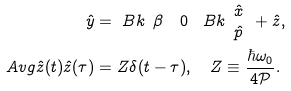<formula> <loc_0><loc_0><loc_500><loc_500>\hat { y } & = \ B k { \begin{array} { c c } \beta & 0 \end{array} } \ B k { \begin{array} { c } \hat { x } \\ \hat { p } \end{array} } + \hat { z } , \\ \ A v g { \hat { z } ( t ) \hat { z } ( \tau ) } & = Z \delta ( t - \tau ) , \quad Z \equiv \frac { \hbar { \omega } _ { 0 } } { 4 \mathcal { P } } .</formula> 